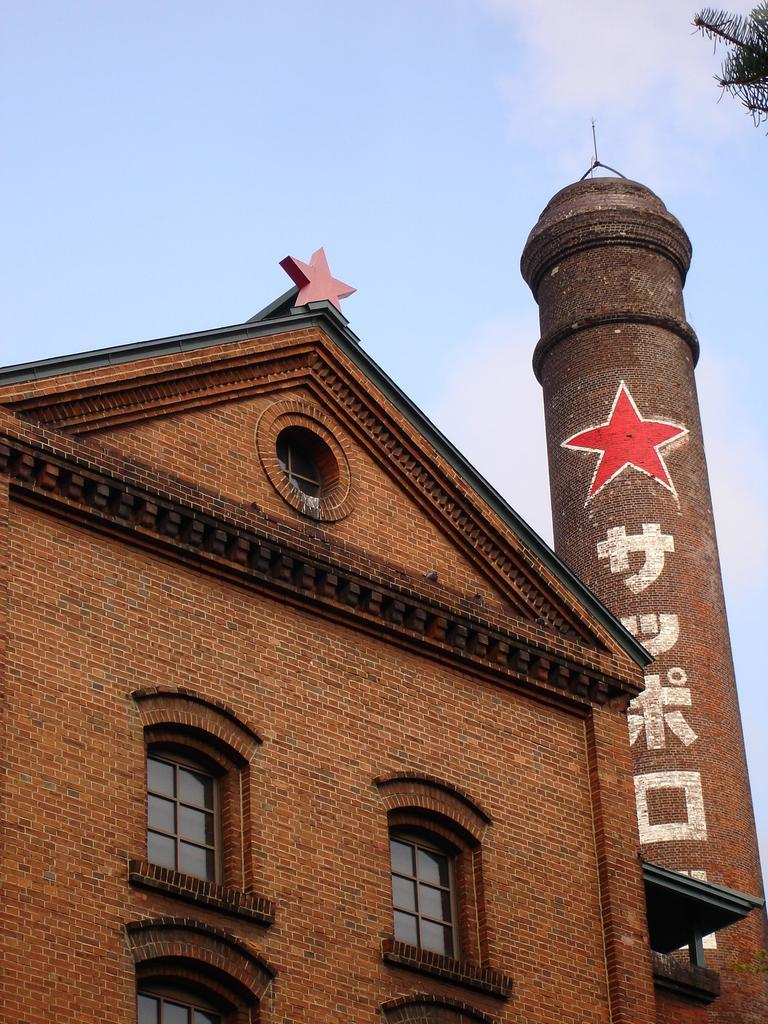What can be seen in the center of the image? The sky is visible in the center of the image. What type of vegetation is present in the image? There are branches with leaves in the image. How many buildings can be seen in the image? There is one building in the image. What type of structure is present in the image? A brick wall is present in the image. What is written or displayed on an object in the image? There is text on a pillar-like object in the image. What architectural feature is visible in the image? Windows are visible in the image. Can you describe any other objects in the image? There are a few other objects in the image. What type of flowers can be seen growing on the brick wall in the image? There are no flowers visible on the brick wall in the image. How does the flock of birds interact with the building in the image? There are no birds or flocks present in the image. 